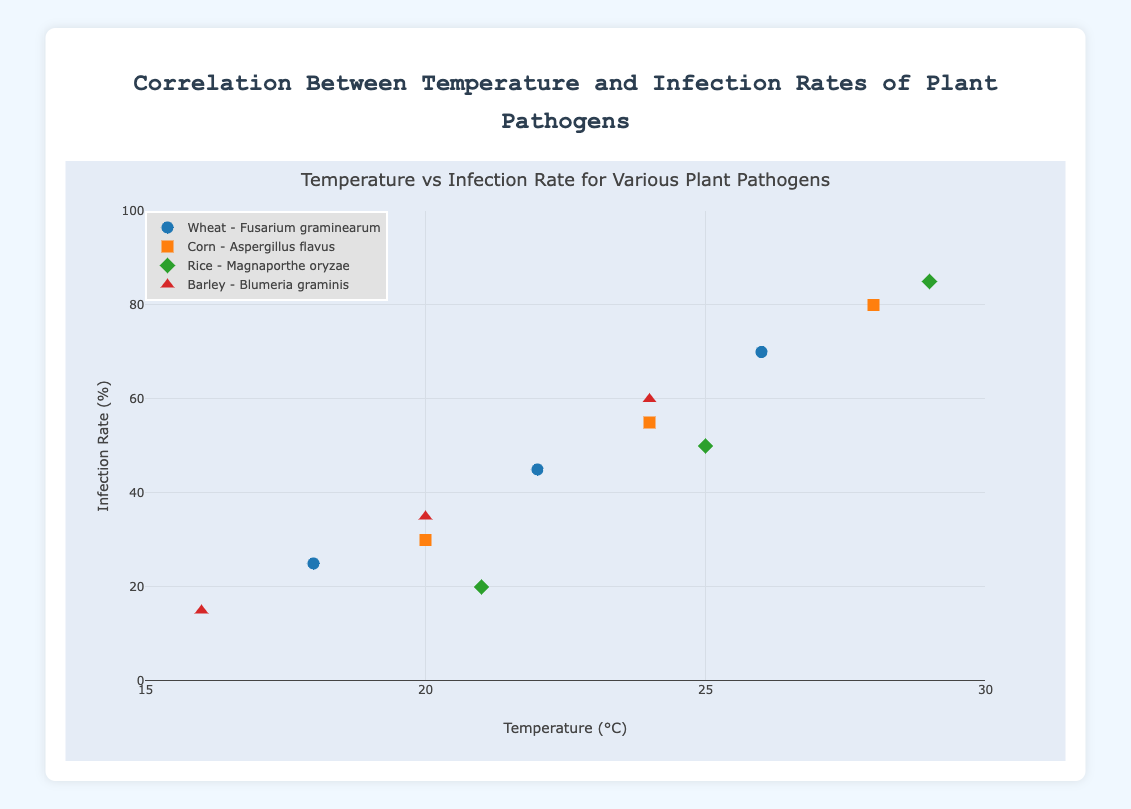What is the temperature range shown for Wheat infected by Fusarium graminearum? The x-axis indicates temperature in °C. For Wheat infected by Fusarium graminearum, the data points are at temperatures 18°C, 22°C, and 26°C.
Answer: 18°C to 26°C What is the infection rate for Corn at a temperature of 28°C? Observing the y-axis and the point specifically labeled as Corn - Aspergillus flavus at 28°C on the x-axis, this point corresponds to an infection rate of 80%.
Answer: 80% Which crop-pathogen combination has the highest recorded infection rate? By assessing all the plotted points on the y-axis, Rice infected by Magnaporthe oryzae shows an infection rate of 85% at 29°C, which is higher than any other point on the graph.
Answer: Rice - Magnaporthe oryzae Are all pathogens found to have higher infection rates at higher temperatures? By looking through each pathogen in the grouped scatter plot, each one shows an increasing trend in infection rates as the temperature rises. For example, Wheat infected by Fusarium graminearum has rates increasing from 25% at 18°C to 70% at 26°C.
Answer: Yes What is the difference in infection rate between the highest and lowest points for Barley infected by Blumeria graminis? the infection rate rises from 15% at 16°C to 60% at 24°C, calculating the difference involves subtracting 15% from 60%.
Answer: 45% Compare the infection rates for Wheat infected by Fusarium graminearum and Corn infected by Aspergillus flavus at their middle temperature points. Wheat infected by Fusarium graminearum at 22°C has an infection rate of 45%, while Corn infected by Aspergillus flavus at 24°C has an infection rate of 55%.
Answer: Corn - Aspergillus flavus has a higher rate Which crop shows the lowest infection rate at the lowest temperature point in the figure? By looking at the lowest temperatures plotted for each crop on the x-axis and their corresponding infection rates on the y-axis, Barley infected by Blumeria graminis shows an infection rate of 15% at 16°C.
Answer: Barley - Blumeria graminis Is there any crop-pathogen combination where the infection rate does not reach 50%? Reviewing each combination's infection rates on the y-axis, Wheat - Fusarium graminearum reaches 70%, Corn - Aspergillus flavus reaches 80%, Rice - Magnaporthe oryzae reaches 85%, and Barley - Blumeria graminis reaches 60%, therefore all reach or exceed 50%.
Answer: No What's the average infection rate of Corn infected by Aspergillus flavus across all temperatures? By identifying the infection rates of Corn - Aspergillus flavus which are 30%, 55%, and 80%, we sum them (30 + 55 + 80) = 165 and divide by 3 to find the average.
Answer: 55% Which pathogen is associated with the highest infection rate for any crop? Observing all the highest infection rate points, 85% is highest and corresponds to Magnaporthe oryzae infecting Rice.
Answer: Magnaporthe oryzae 